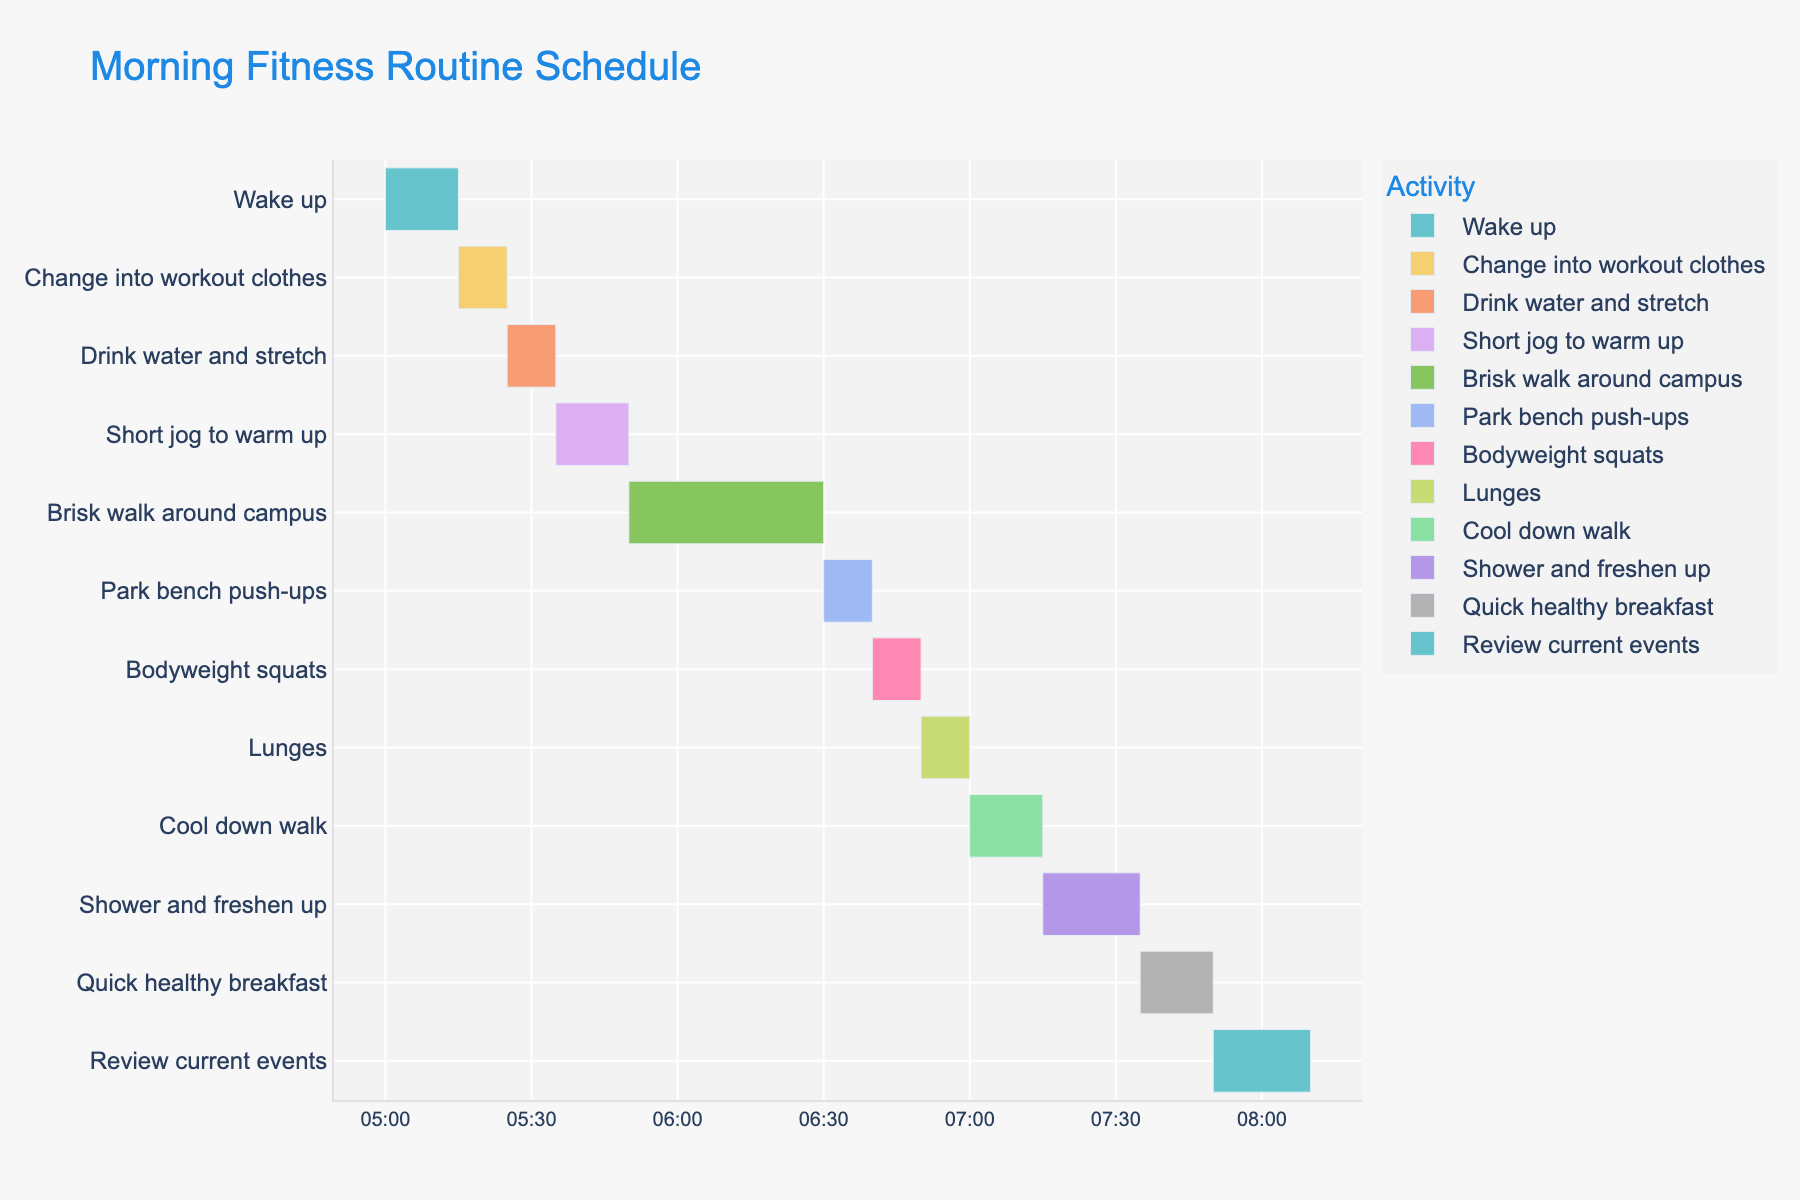What time does the "Brisk walk around campus" start and end? The "Brisk walk around campus" starts at 5:50 AM. Since the duration is 40 minutes, it ends at 6:30 AM.
Answer: 5:50 AM to 6:30 AM How long is the total duration from "Wake up" to "Quick healthy breakfast"? "Wake up" starts at 5:00 AM and "Quick healthy breakfast" ends at 7:50 AM. The total duration is 2 hours and 50 minutes.
Answer: 2 hours and 50 minutes Which task has the shortest duration, and what is its duration? Both "Change into workout clothes" and "Drink water and stretch" have the shortest durations, each lasting 10 minutes.
Answer: Change into workout clothes, 10 minutes What is the latest task in the morning routine, and how long does it last? The latest task is "Review current events," which starts at 7:50 AM and lasts for 20 minutes.
Answer: Review current events, 20 minutes Which exercise tasks are performed consecutively without any break? "Park bench push-ups," "Bodyweight squats," and "Lunges" are performed consecutively from 6:30 AM to 7:00 AM.
Answer: Park bench push-ups, Bodyweight squats, Lunges How much time is allocated for exercises including the cool down walk? Adding up the durations: Short jog to warm up (15 min) + Brisk walk around campus (40 min) + Park bench push-ups (10 min) + Bodyweight squats (10 min) + Lunges (10 min) + Cool down walk (15 min) = 1 hour and 40 minutes.
Answer: 1 hour and 40 minutes What time is scheduled for shower and freshen up? "Shower and freshen up" is scheduled to start at 7:15 AM and ends at 7:35 AM.
Answer: 7:15 AM to 7:35 AM Compare the duration of "Brisk walk around campus" to the combined duration of "Short jog to warm up" and "Cool down walk". The duration of "Brisk walk around campus" is 40 minutes. The combined duration of "Short jog to warm up" (15 min) and "Cool down walk" (15 min) is 30 minutes. So, the "Brisk walk around campus" is longer by 10 minutes.
Answer: Brisk walk around campus is longer by 10 minutes How many tasks in total are scheduled in the routine? There are 12 tasks listed in the routine.
Answer: 12 